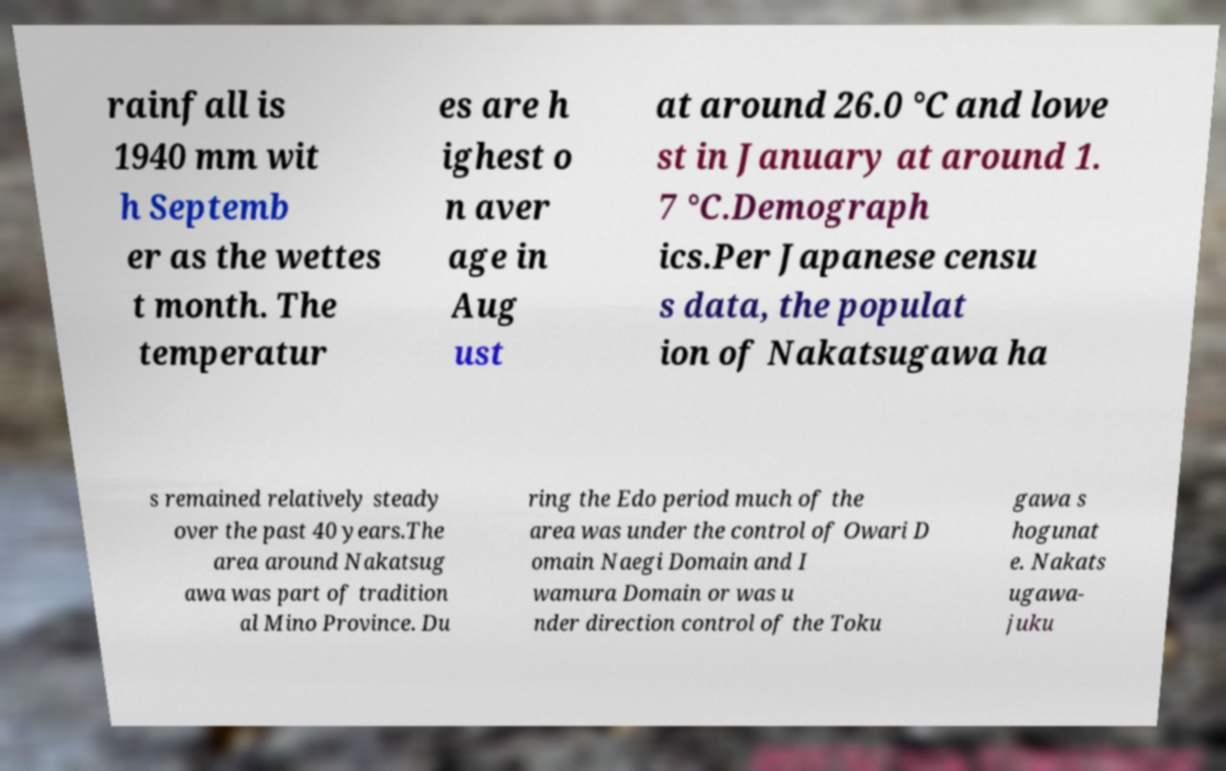For documentation purposes, I need the text within this image transcribed. Could you provide that? rainfall is 1940 mm wit h Septemb er as the wettes t month. The temperatur es are h ighest o n aver age in Aug ust at around 26.0 °C and lowe st in January at around 1. 7 °C.Demograph ics.Per Japanese censu s data, the populat ion of Nakatsugawa ha s remained relatively steady over the past 40 years.The area around Nakatsug awa was part of tradition al Mino Province. Du ring the Edo period much of the area was under the control of Owari D omain Naegi Domain and I wamura Domain or was u nder direction control of the Toku gawa s hogunat e. Nakats ugawa- juku 